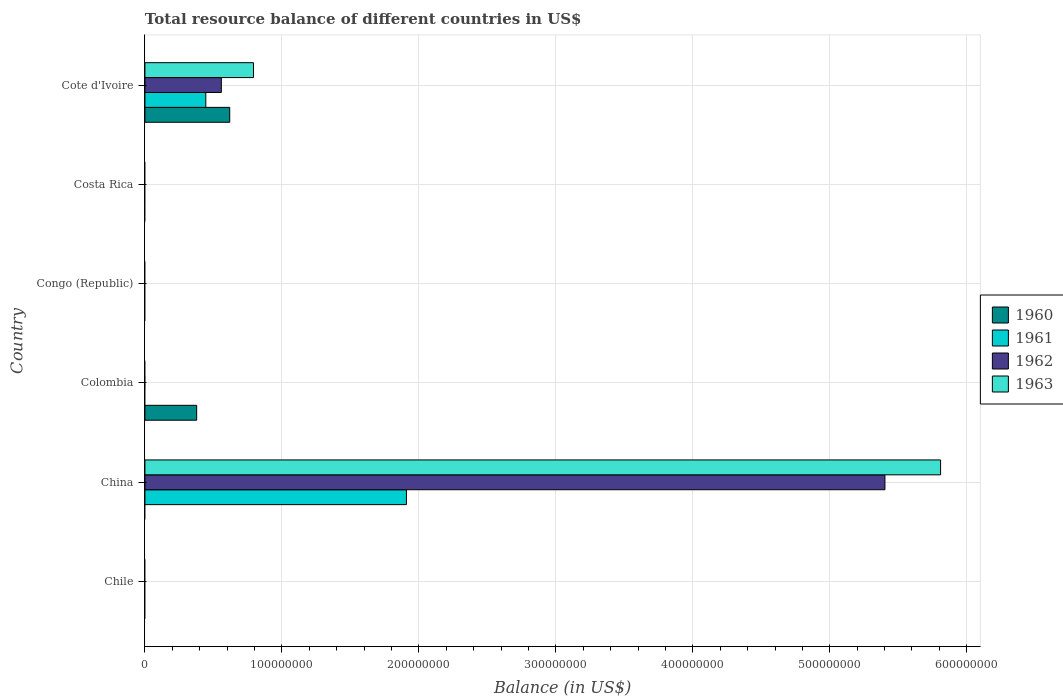Are the number of bars per tick equal to the number of legend labels?
Make the answer very short. No. How many bars are there on the 1st tick from the top?
Provide a succinct answer. 4. How many bars are there on the 3rd tick from the bottom?
Ensure brevity in your answer.  1. What is the label of the 2nd group of bars from the top?
Offer a terse response. Costa Rica. Across all countries, what is the maximum total resource balance in 1962?
Your answer should be compact. 5.40e+08. What is the total total resource balance in 1962 in the graph?
Your response must be concise. 5.96e+08. What is the difference between the total resource balance in 1960 in Colombia and that in Cote d'Ivoire?
Provide a short and direct response. -2.41e+07. What is the average total resource balance in 1961 per country?
Offer a terse response. 3.92e+07. What is the difference between the total resource balance in 1961 and total resource balance in 1962 in Cote d'Ivoire?
Provide a succinct answer. -1.13e+07. In how many countries, is the total resource balance in 1961 greater than 380000000 US$?
Offer a very short reply. 0. What is the difference between the highest and the lowest total resource balance in 1960?
Provide a succinct answer. 6.19e+07. How many bars are there?
Offer a terse response. 8. How many countries are there in the graph?
Your response must be concise. 6. What is the difference between two consecutive major ticks on the X-axis?
Ensure brevity in your answer.  1.00e+08. Does the graph contain any zero values?
Offer a very short reply. Yes. Where does the legend appear in the graph?
Provide a short and direct response. Center right. How are the legend labels stacked?
Keep it short and to the point. Vertical. What is the title of the graph?
Give a very brief answer. Total resource balance of different countries in US$. Does "1990" appear as one of the legend labels in the graph?
Provide a short and direct response. No. What is the label or title of the X-axis?
Your answer should be compact. Balance (in US$). What is the label or title of the Y-axis?
Your answer should be compact. Country. What is the Balance (in US$) of 1960 in Chile?
Make the answer very short. 0. What is the Balance (in US$) of 1962 in Chile?
Offer a very short reply. 0. What is the Balance (in US$) in 1960 in China?
Your answer should be very brief. 0. What is the Balance (in US$) in 1961 in China?
Your answer should be compact. 1.91e+08. What is the Balance (in US$) of 1962 in China?
Provide a short and direct response. 5.40e+08. What is the Balance (in US$) of 1963 in China?
Offer a very short reply. 5.81e+08. What is the Balance (in US$) of 1960 in Colombia?
Give a very brief answer. 3.78e+07. What is the Balance (in US$) in 1961 in Colombia?
Give a very brief answer. 0. What is the Balance (in US$) of 1962 in Colombia?
Your response must be concise. 0. What is the Balance (in US$) of 1963 in Colombia?
Ensure brevity in your answer.  0. What is the Balance (in US$) of 1960 in Congo (Republic)?
Your answer should be compact. 0. What is the Balance (in US$) of 1961 in Congo (Republic)?
Provide a short and direct response. 0. What is the Balance (in US$) in 1962 in Congo (Republic)?
Give a very brief answer. 0. What is the Balance (in US$) in 1962 in Costa Rica?
Your answer should be compact. 0. What is the Balance (in US$) of 1963 in Costa Rica?
Your response must be concise. 0. What is the Balance (in US$) in 1960 in Cote d'Ivoire?
Provide a short and direct response. 6.19e+07. What is the Balance (in US$) of 1961 in Cote d'Ivoire?
Your answer should be very brief. 4.44e+07. What is the Balance (in US$) in 1962 in Cote d'Ivoire?
Provide a succinct answer. 5.58e+07. What is the Balance (in US$) of 1963 in Cote d'Ivoire?
Offer a very short reply. 7.93e+07. Across all countries, what is the maximum Balance (in US$) of 1960?
Ensure brevity in your answer.  6.19e+07. Across all countries, what is the maximum Balance (in US$) of 1961?
Your answer should be compact. 1.91e+08. Across all countries, what is the maximum Balance (in US$) of 1962?
Provide a short and direct response. 5.40e+08. Across all countries, what is the maximum Balance (in US$) of 1963?
Offer a terse response. 5.81e+08. Across all countries, what is the minimum Balance (in US$) of 1961?
Your response must be concise. 0. Across all countries, what is the minimum Balance (in US$) of 1963?
Offer a terse response. 0. What is the total Balance (in US$) of 1960 in the graph?
Offer a terse response. 9.97e+07. What is the total Balance (in US$) in 1961 in the graph?
Keep it short and to the point. 2.35e+08. What is the total Balance (in US$) of 1962 in the graph?
Offer a very short reply. 5.96e+08. What is the total Balance (in US$) of 1963 in the graph?
Give a very brief answer. 6.60e+08. What is the difference between the Balance (in US$) of 1961 in China and that in Cote d'Ivoire?
Provide a succinct answer. 1.46e+08. What is the difference between the Balance (in US$) of 1962 in China and that in Cote d'Ivoire?
Your response must be concise. 4.84e+08. What is the difference between the Balance (in US$) in 1963 in China and that in Cote d'Ivoire?
Your answer should be very brief. 5.02e+08. What is the difference between the Balance (in US$) of 1960 in Colombia and that in Cote d'Ivoire?
Offer a very short reply. -2.41e+07. What is the difference between the Balance (in US$) of 1961 in China and the Balance (in US$) of 1962 in Cote d'Ivoire?
Your answer should be very brief. 1.35e+08. What is the difference between the Balance (in US$) of 1961 in China and the Balance (in US$) of 1963 in Cote d'Ivoire?
Your answer should be very brief. 1.12e+08. What is the difference between the Balance (in US$) of 1962 in China and the Balance (in US$) of 1963 in Cote d'Ivoire?
Keep it short and to the point. 4.61e+08. What is the difference between the Balance (in US$) of 1960 in Colombia and the Balance (in US$) of 1961 in Cote d'Ivoire?
Your response must be concise. -6.67e+06. What is the difference between the Balance (in US$) in 1960 in Colombia and the Balance (in US$) in 1962 in Cote d'Ivoire?
Provide a short and direct response. -1.80e+07. What is the difference between the Balance (in US$) in 1960 in Colombia and the Balance (in US$) in 1963 in Cote d'Ivoire?
Keep it short and to the point. -4.15e+07. What is the average Balance (in US$) of 1960 per country?
Provide a short and direct response. 1.66e+07. What is the average Balance (in US$) in 1961 per country?
Make the answer very short. 3.92e+07. What is the average Balance (in US$) in 1962 per country?
Keep it short and to the point. 9.93e+07. What is the average Balance (in US$) of 1963 per country?
Provide a short and direct response. 1.10e+08. What is the difference between the Balance (in US$) in 1961 and Balance (in US$) in 1962 in China?
Your answer should be compact. -3.49e+08. What is the difference between the Balance (in US$) of 1961 and Balance (in US$) of 1963 in China?
Make the answer very short. -3.90e+08. What is the difference between the Balance (in US$) in 1962 and Balance (in US$) in 1963 in China?
Your answer should be very brief. -4.06e+07. What is the difference between the Balance (in US$) of 1960 and Balance (in US$) of 1961 in Cote d'Ivoire?
Offer a terse response. 1.75e+07. What is the difference between the Balance (in US$) in 1960 and Balance (in US$) in 1962 in Cote d'Ivoire?
Offer a very short reply. 6.12e+06. What is the difference between the Balance (in US$) of 1960 and Balance (in US$) of 1963 in Cote d'Ivoire?
Your answer should be very brief. -1.74e+07. What is the difference between the Balance (in US$) in 1961 and Balance (in US$) in 1962 in Cote d'Ivoire?
Provide a short and direct response. -1.13e+07. What is the difference between the Balance (in US$) of 1961 and Balance (in US$) of 1963 in Cote d'Ivoire?
Offer a terse response. -3.48e+07. What is the difference between the Balance (in US$) of 1962 and Balance (in US$) of 1963 in Cote d'Ivoire?
Provide a short and direct response. -2.35e+07. What is the ratio of the Balance (in US$) of 1961 in China to that in Cote d'Ivoire?
Your answer should be compact. 4.3. What is the ratio of the Balance (in US$) in 1962 in China to that in Cote d'Ivoire?
Provide a short and direct response. 9.68. What is the ratio of the Balance (in US$) in 1963 in China to that in Cote d'Ivoire?
Ensure brevity in your answer.  7.33. What is the ratio of the Balance (in US$) of 1960 in Colombia to that in Cote d'Ivoire?
Give a very brief answer. 0.61. What is the difference between the highest and the lowest Balance (in US$) in 1960?
Your answer should be compact. 6.19e+07. What is the difference between the highest and the lowest Balance (in US$) of 1961?
Ensure brevity in your answer.  1.91e+08. What is the difference between the highest and the lowest Balance (in US$) in 1962?
Offer a very short reply. 5.40e+08. What is the difference between the highest and the lowest Balance (in US$) in 1963?
Ensure brevity in your answer.  5.81e+08. 